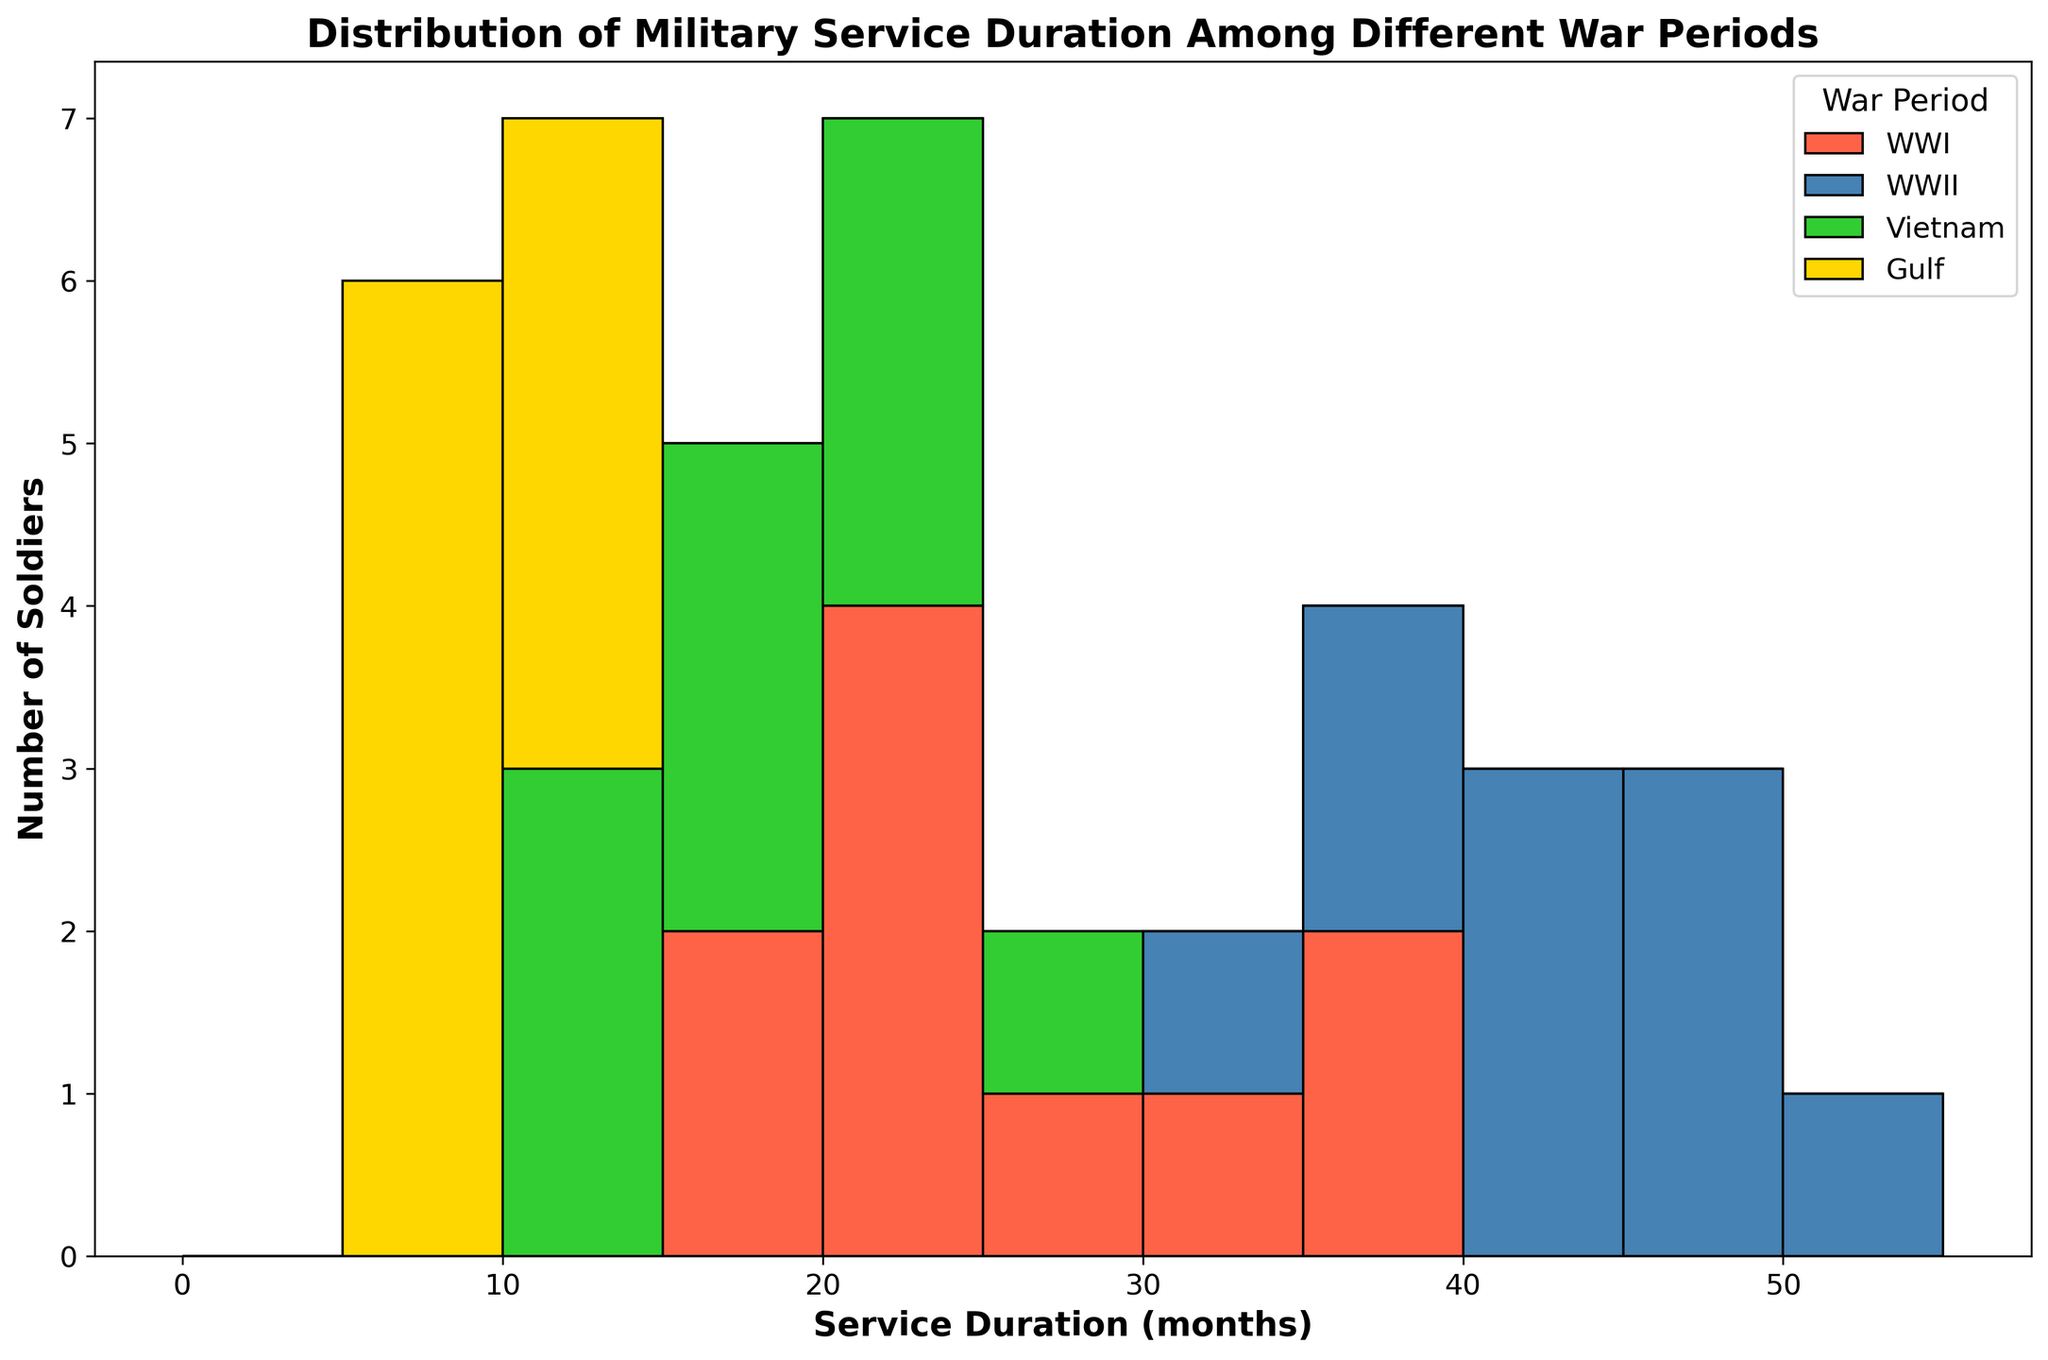How is the distribution of service durations different between WWI and WWII? To determine the distribution difference, look at the range and concentration of the service durations for both periods. WWI shows a range mostly between 18 to 36 months with a concentration around 24-28 months. In contrast, WWII shows a broader range from 34 to 50 months with a higher concentration around 36-46 months.
Answer: Service durations were generally longer and more varied in WWII compared to WWI Which war period had the shortest recorded service duration and what was it? The shortest recorded service duration is observed in the Gulf War period. By examining the histogram, we see bars starting from 6 months for the Gulf War, which is the shortest among all periods displayed.
Answer: Gulf War, 6 months What is the most frequent service duration range for soldiers in the Vietnam War? To find the most frequent service duration, check the height of the bars for the Vietnam War within each range. The tallest bars in the Vietnam War period are between 12 and 18 months, indicating the highest frequency in this duration range.
Answer: 12-18 months How do the service durations of the Gulf War compare with those of WWI in terms of the range and concentration? For the Gulf War, service durations range from 6 to 12 months, with higher concentrations around the 6-10 months period. In WWI, durations range from 18 to 36 months, concentrated around 24-28 months. The Gulf War has a shorter duration range and lower values compared to WWI.
Answer: Gulf War had shorter and less variable service durations compared to WWI Which war period exhibited the longest service durations and what was the longest service time? By examining the histogram for all war periods, the WWII period displays the longest service duration bars going up to 50 months, which is the highest duration in the dataset.
Answer: WWII, 50 months Compare the frequency of service durations in the 20-25 months range between WWI and Vietnam War. The frequency corresponds to the height of bars in the 20-25 months range for both wars. WWI shows a moderate concentration in this range, whereas the Vietnam War has fewer bars and less concentration in this range, indicating lower frequency.
Answer: More frequent in WWI than Vietnam War What are the main differences in the visual representation for the service durations of WWII and Vietnam War? Visually, the WWII histogram has taller and broader bars in the upper duration ranges (36-50 months), indicating more extended and varied durations. On the other hand, the Vietnam War shows shorter bars peaking in the 12-18 months range, reflecting shorter durations.
Answer: WWII has taller and broader bars (more extended durations), Vietnam War has shorter bars (shorter durations) What can be inferred about the consistency of service durations in each war period? Consistency can be inferred from the range and uniformity of the bars in each period. WWI shows moderate consistency with most bars around 24-28 months. WWII displays variability with a spread of durations. Vietnam War appears more consistent with many soldiers serving 12-18 months. The Gulf War is highly consistent with most durations between 6-12 months.
Answer: Gulf War and Vietnam War show higher consistency, WWI moderate, WWII least consistent 